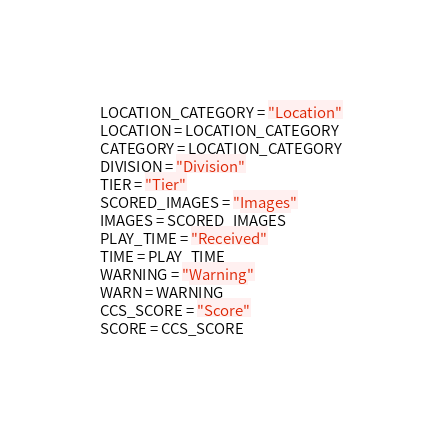<code> <loc_0><loc_0><loc_500><loc_500><_Python_>LOCATION_CATEGORY = "Location"
LOCATION = LOCATION_CATEGORY
CATEGORY = LOCATION_CATEGORY
DIVISION = "Division"
TIER = "Tier"
SCORED_IMAGES = "Images"
IMAGES = SCORED_IMAGES
PLAY_TIME = "Received"
TIME = PLAY_TIME
WARNING = "Warning"
WARN = WARNING
CCS_SCORE = "Score"
SCORE = CCS_SCORE</code> 